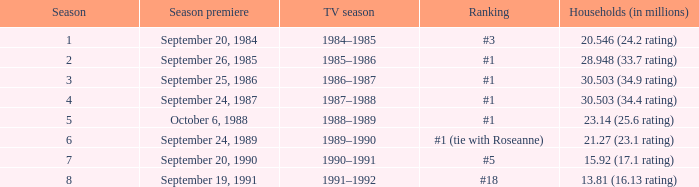Which TV season has a Season larger than 2, and a Ranking of #5? 1990–1991. 